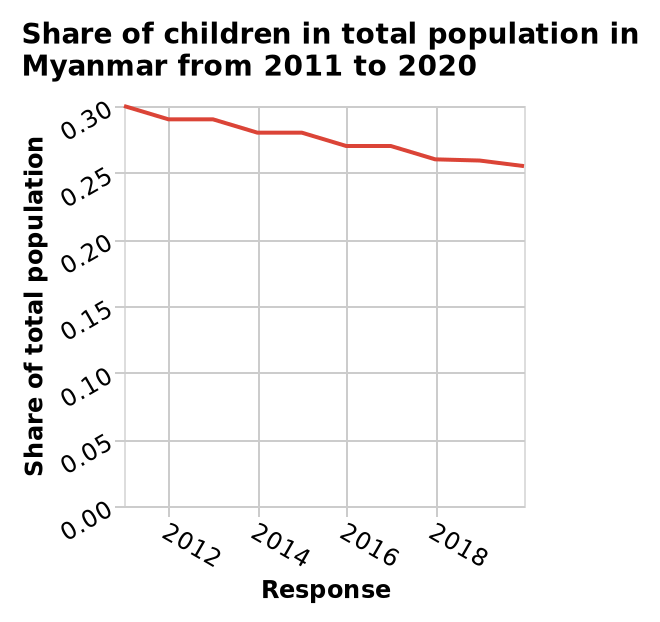<image>
Can the response go below 0.25? The given information does not specify whether the response can go below 0.25. What is plotted on the y-axis of the line plot?  The y-axis of the line plot measures the share of the total population. What is plotted on the x-axis of the line plot? The x-axis of the line plot measures the response. please enumerates aspects of the construction of the chart Here a is a line plot named Share of children in total population in Myanmar from 2011 to 2020. The y-axis plots Share of total population while the x-axis measures Response. What is the specific country for which the line plot represents data? The line plot represents data for Myanmar. 